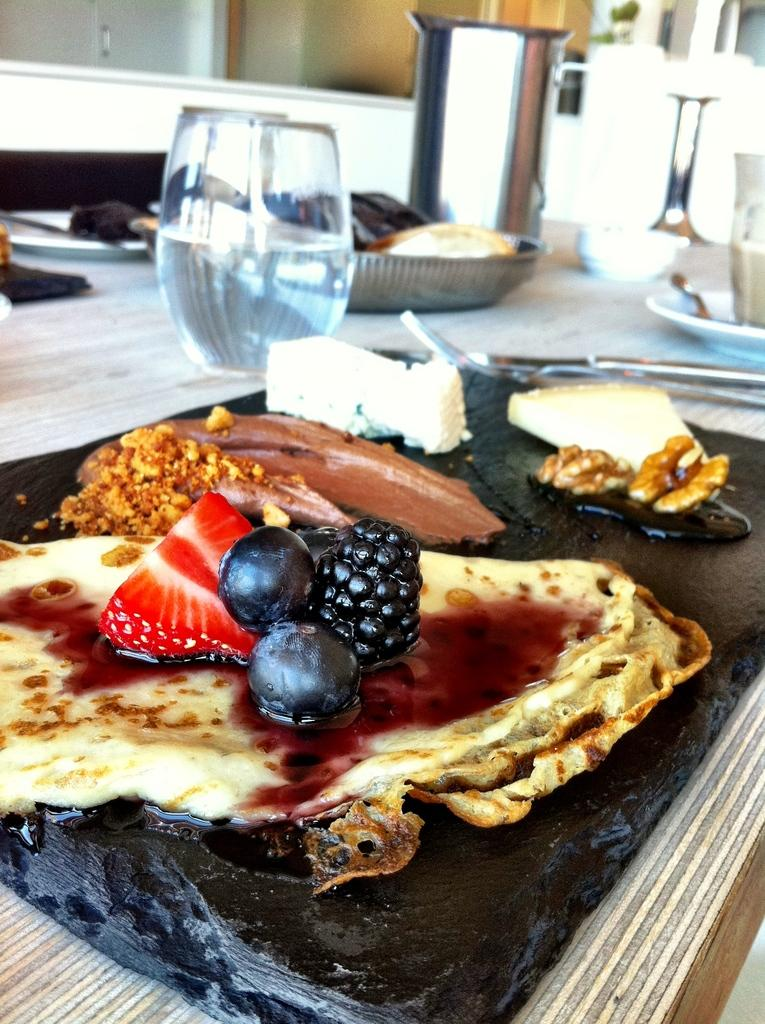What material is the table made of in the image? The table is made of wood. What type of container is on the table? There is a glass on the table. What else can be seen on the table besides the glass? There is a bowl, plates, a jar, and other objects on the table. What is inside the bowl? The bowl contains food items. What type of flower is blooming on the table in the image? There is no flower present on the table in the image. 